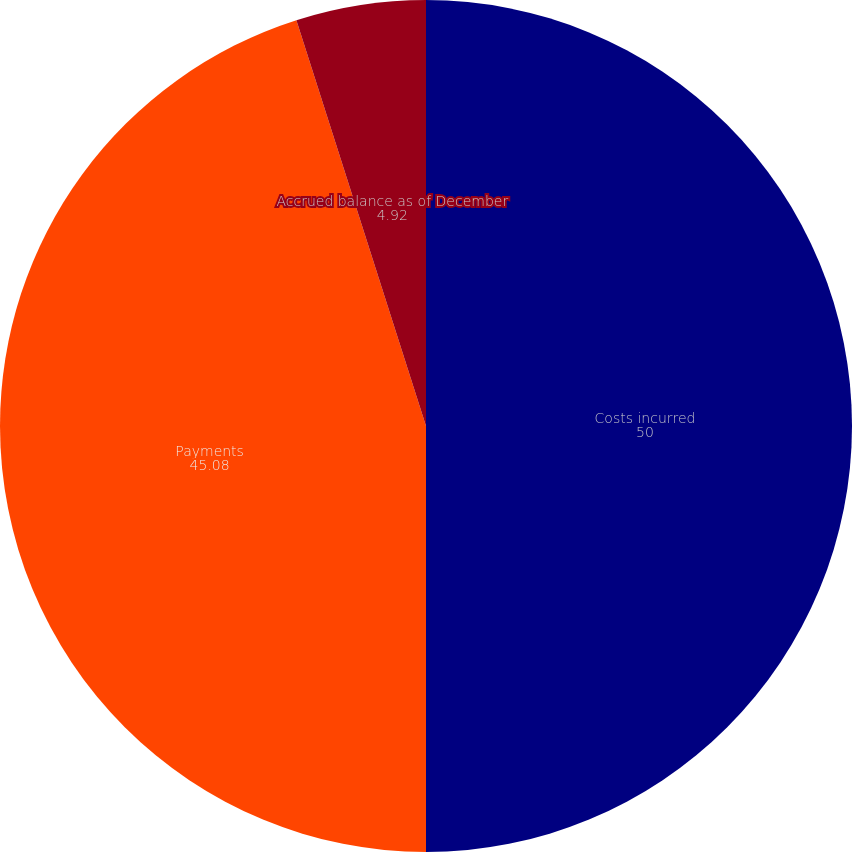<chart> <loc_0><loc_0><loc_500><loc_500><pie_chart><fcel>Costs incurred<fcel>Payments<fcel>Accrued balance as of December<nl><fcel>50.0%<fcel>45.08%<fcel>4.92%<nl></chart> 